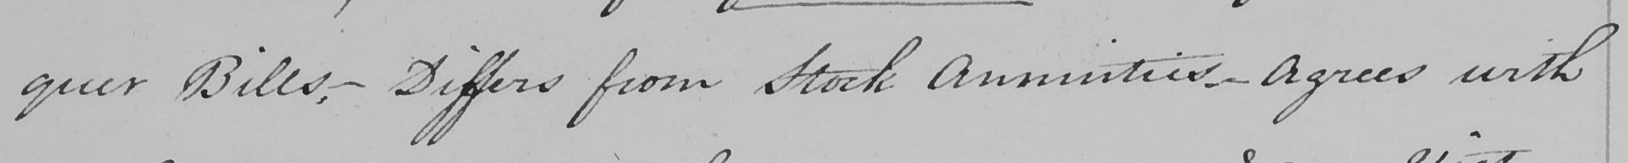Please provide the text content of this handwritten line. quer Bills , _  Differs from Stock Annuities  _  Agrees with 